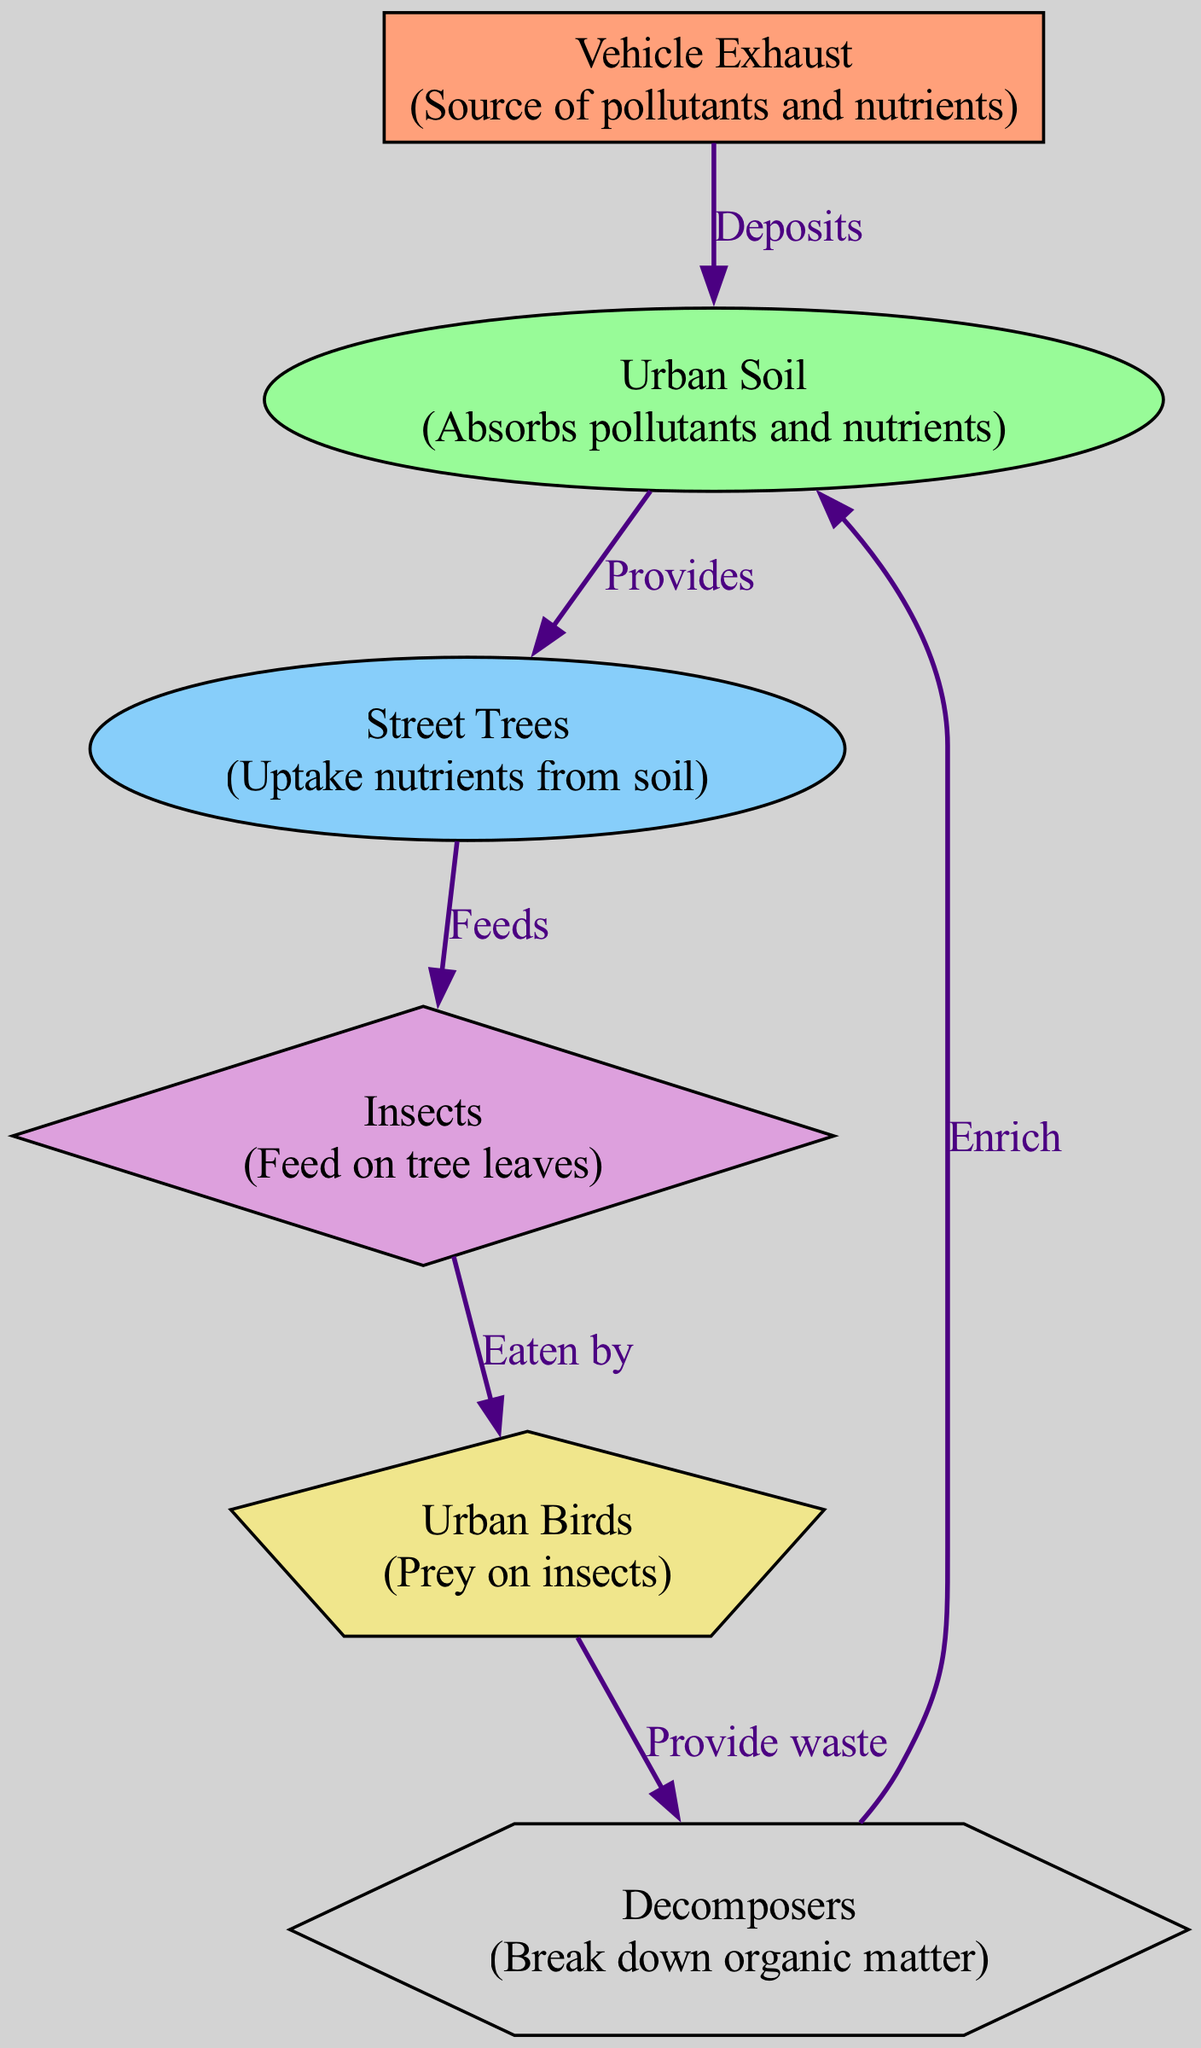What is the first element in the nutrient flow? The first element is "Vehicle Exhaust," which is labeled as the source of pollutants and nutrients in the diagram. It initiates the flow of nutrients and pollutants into the urban ecosystem.
Answer: Vehicle Exhaust How many primary consumers are in the diagram? There is one primary consumer, which is "Urban Soil." It absorbs both pollutants and nutrients, thus playing a crucial role in the nutrient flow.
Answer: 1 What does Urban Soil provide to Street Trees? Urban Soil provides nutrients to Street Trees, enabling them to thrive in the urban ecosystem. This connection is labeled as "Provides" in the diagram.
Answer: Nutrients What is the resource flow from Insects to Urban Birds? Insects are eaten by Urban Birds, establishing a food chain relationship where Urban Birds rely on Insects as their prey. This connection is labeled as "Eaten by."
Answer: Eaten by What role do Decomposers play in the nutrient flow? Decomposers break down organic matter, and their action enriches Urban Soil, completing the cycle of nutrient flow within the ecosystem. This role is highlighted in the connection labeled "Enrich."
Answer: Recycler Which element is a tertiary consumer? "Insects" are identified as a tertiary consumer. They feed on the leaves of Street Trees, thus serving as a crucial link in the urban food chain.
Answer: Insects How do Urban Birds contribute back to the nutrient cycle? Urban Birds provide waste that is an organic input for Decomposers, facilitating nutrient recycling in the ecosystem. This relationship enhances soil health and is represented by the label "Provide waste."
Answer: Provide waste What is the relationship between Street Trees and Urban Soil? Street Trees receive nutrients from Urban Soil, which is essential for their growth. This connection is labeled as "Provides" in the diagram, illustrating their dependency.
Answer: Provides How many quaternary consumers are in the diagram? There is one quaternary consumer identified, which is "Urban Birds." This categorization is based on their position in the food chain, where they prey on insects.
Answer: 1 